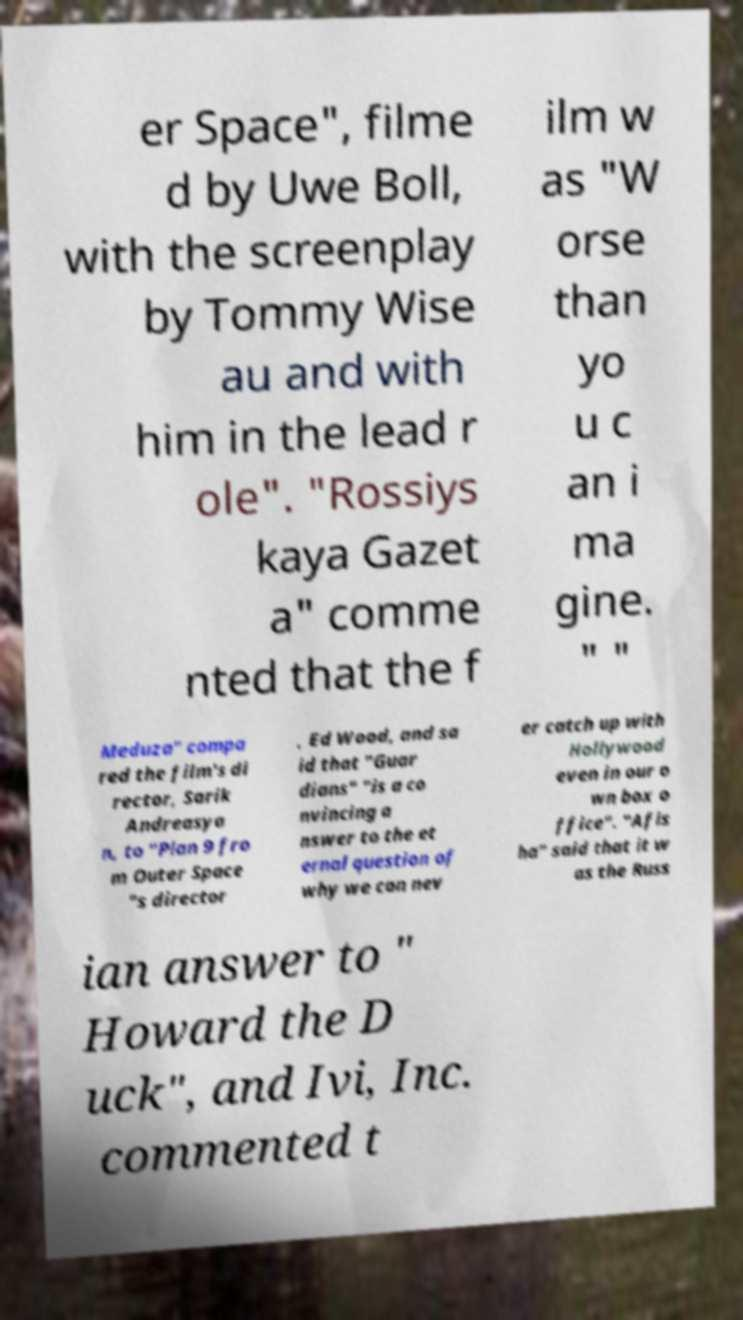For documentation purposes, I need the text within this image transcribed. Could you provide that? er Space", filme d by Uwe Boll, with the screenplay by Tommy Wise au and with him in the lead r ole". "Rossiys kaya Gazet a" comme nted that the f ilm w as "W orse than yo u c an i ma gine. " " Meduza" compa red the film's di rector, Sarik Andreasya n, to "Plan 9 fro m Outer Space "s director , Ed Wood, and sa id that "Guar dians" "is a co nvincing a nswer to the et ernal question of why we can nev er catch up with Hollywood even in our o wn box o ffice". "Afis ha" said that it w as the Russ ian answer to " Howard the D uck", and Ivi, Inc. commented t 